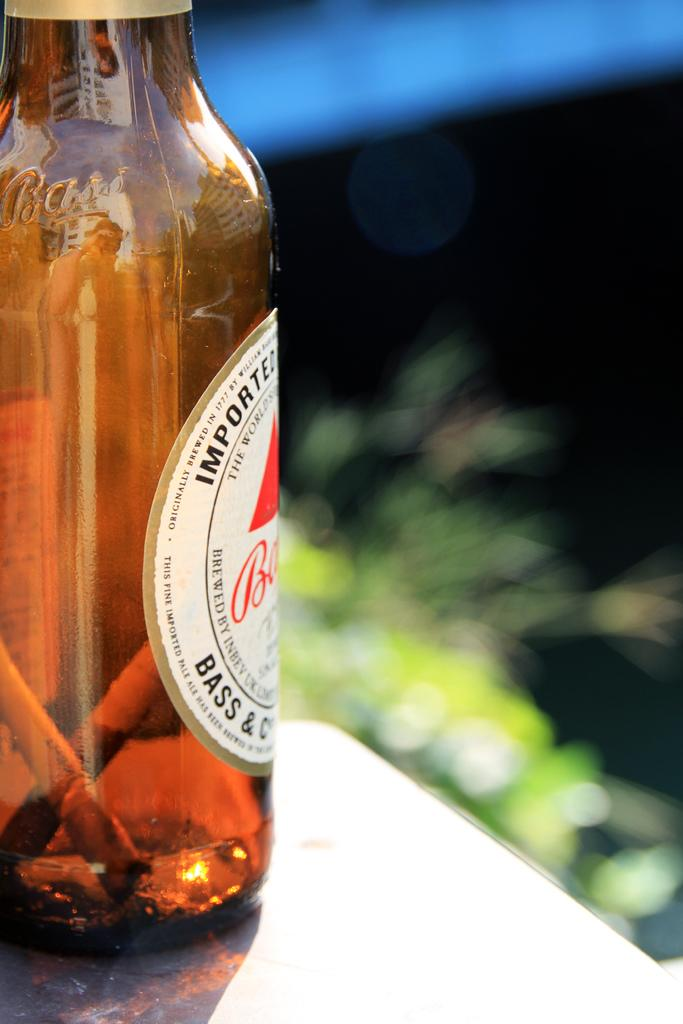<image>
Provide a brief description of the given image. a bottle of imported beer next to the corner of a counter 